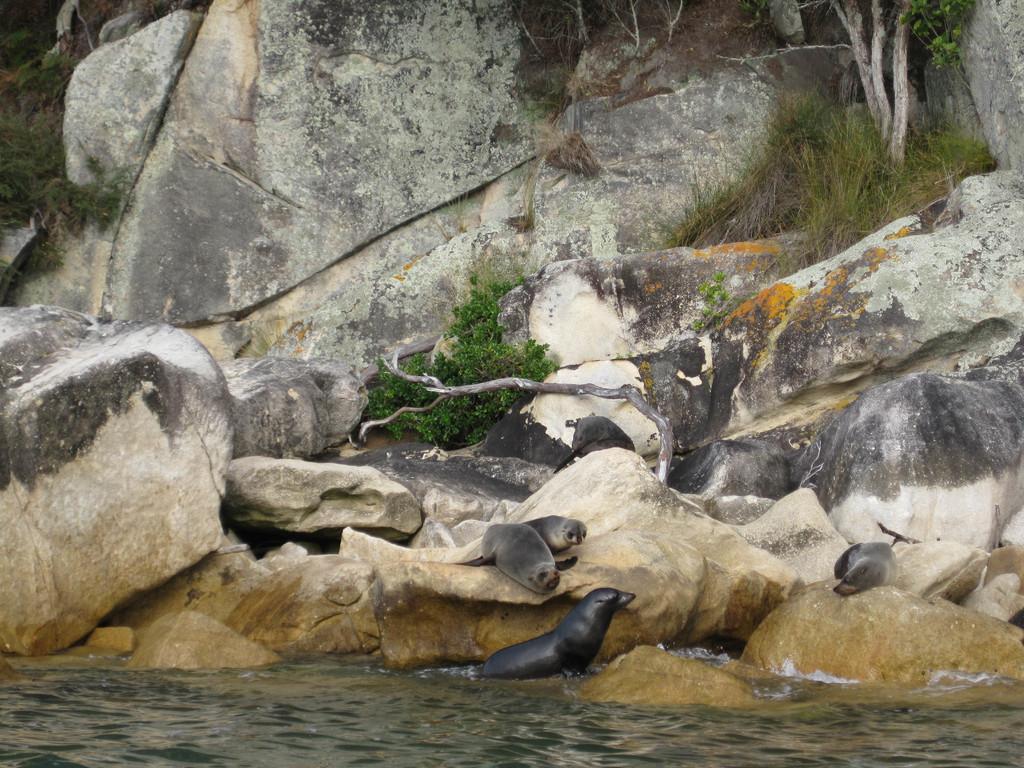In one or two sentences, can you explain what this image depicts? In this picture, we see seals. At the bottom of the picture, we see water and this water might be in the lake. In the background, we see grass, trees and rocks. 